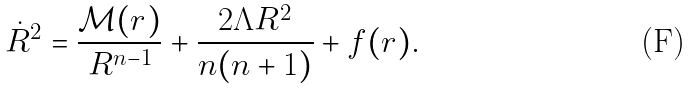Convert formula to latex. <formula><loc_0><loc_0><loc_500><loc_500>\dot { R } ^ { 2 } = \frac { \mathcal { M } ( r ) } { R ^ { n - 1 } } + \frac { 2 \Lambda R ^ { 2 } } { n ( n + 1 ) } + f ( r ) .</formula> 